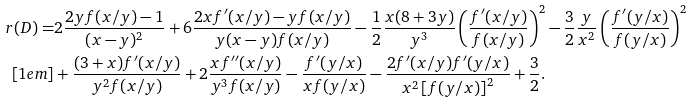<formula> <loc_0><loc_0><loc_500><loc_500>r ( D ) = & 2 \frac { 2 y f ( x / y ) - 1 } { ( x - y ) ^ { 2 } } + 6 \frac { 2 x f ^ { \prime } ( x / y ) - y f ( x / y ) } { y ( x - y ) f ( x / y ) } - \frac { 1 } { 2 } \frac { x ( 8 + 3 y ) } { y ^ { 3 } } \left ( \frac { f ^ { \prime } ( x / y ) } { f ( x / y ) } \right ) ^ { 2 } - \frac { 3 } { 2 } \frac { y } { x ^ { 2 } } \left ( \frac { f ^ { \prime } ( y / x ) } { f ( y / x ) } \right ) ^ { 2 } \\ [ 1 e m ] & + \frac { ( 3 + x ) f ^ { \prime } ( x / y ) } { y ^ { 2 } f ( x / y ) } + 2 \frac { x f ^ { \prime \prime } ( x / y ) } { y ^ { 3 } f ( x / y ) } - \frac { f ^ { \prime } ( y / x ) } { x f ( y / x ) } - \frac { 2 f ^ { \prime } ( x / y ) f ^ { \prime } ( y / x ) } { x ^ { 2 } \left [ f ( y / x ) \right ] ^ { 2 } } + \frac { 3 } { 2 } .</formula> 